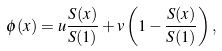Convert formula to latex. <formula><loc_0><loc_0><loc_500><loc_500>\phi ( x ) = u \frac { S ( x ) } { S ( 1 ) } + v \left ( 1 - \frac { S ( x ) } { S ( 1 ) } \right ) ,</formula> 